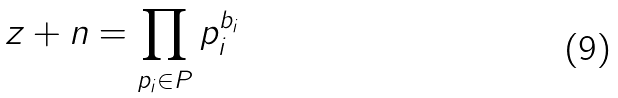<formula> <loc_0><loc_0><loc_500><loc_500>z + n = \prod _ { p _ { i } \in P } p _ { i } ^ { b _ { i } }</formula> 